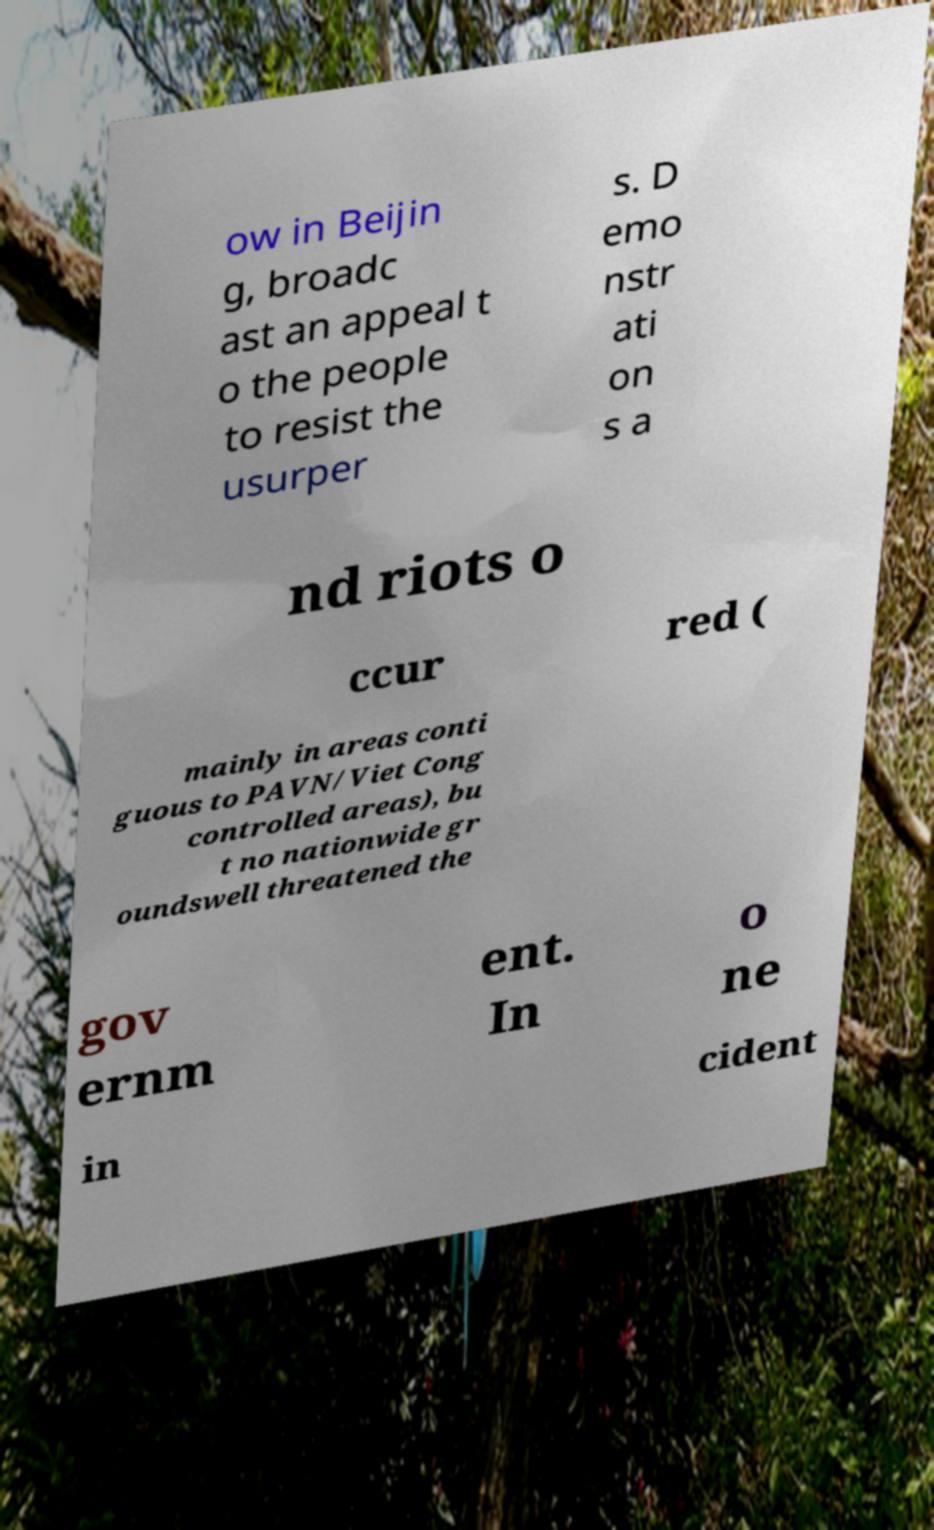What messages or text are displayed in this image? I need them in a readable, typed format. ow in Beijin g, broadc ast an appeal t o the people to resist the usurper s. D emo nstr ati on s a nd riots o ccur red ( mainly in areas conti guous to PAVN/Viet Cong controlled areas), bu t no nationwide gr oundswell threatened the gov ernm ent. In o ne in cident 